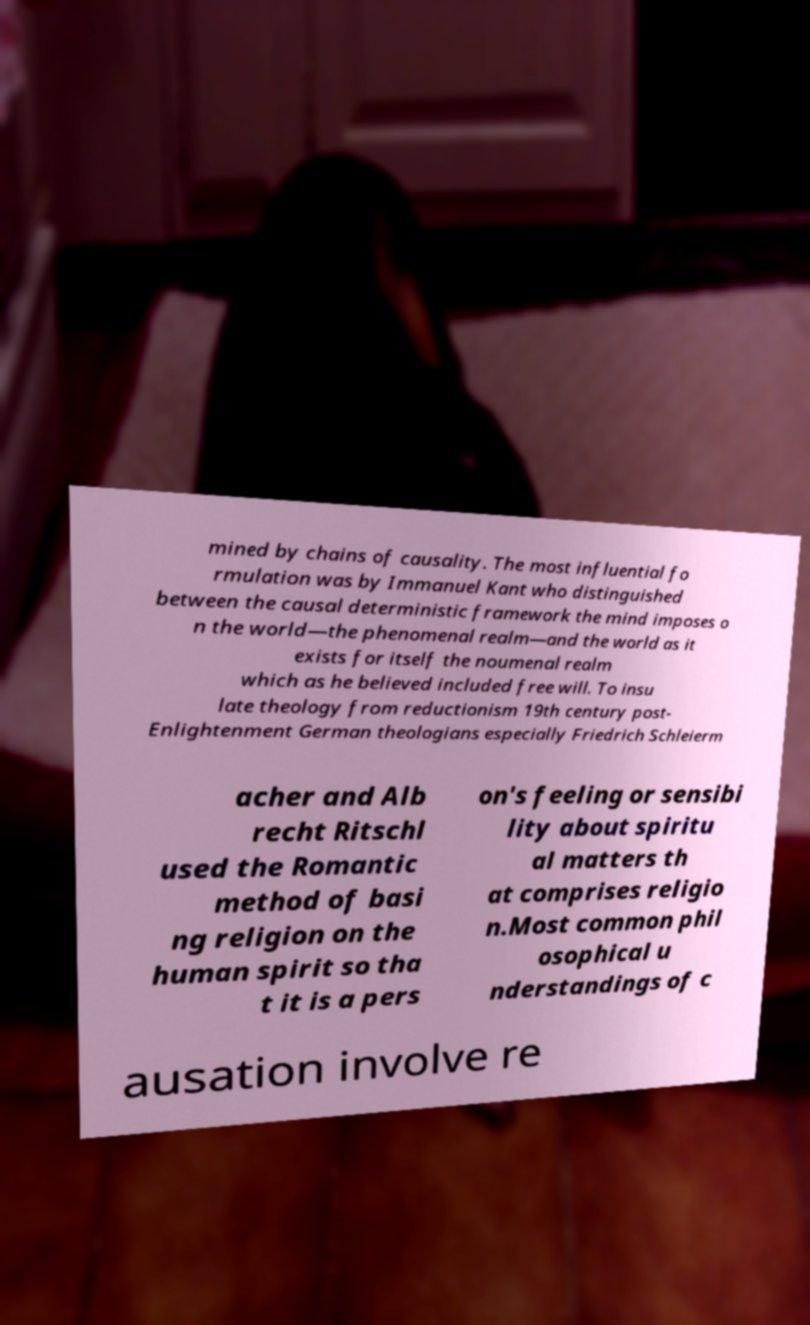Please identify and transcribe the text found in this image. mined by chains of causality. The most influential fo rmulation was by Immanuel Kant who distinguished between the causal deterministic framework the mind imposes o n the world—the phenomenal realm—and the world as it exists for itself the noumenal realm which as he believed included free will. To insu late theology from reductionism 19th century post- Enlightenment German theologians especially Friedrich Schleierm acher and Alb recht Ritschl used the Romantic method of basi ng religion on the human spirit so tha t it is a pers on's feeling or sensibi lity about spiritu al matters th at comprises religio n.Most common phil osophical u nderstandings of c ausation involve re 